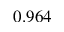<formula> <loc_0><loc_0><loc_500><loc_500>0 . 9 6 4</formula> 